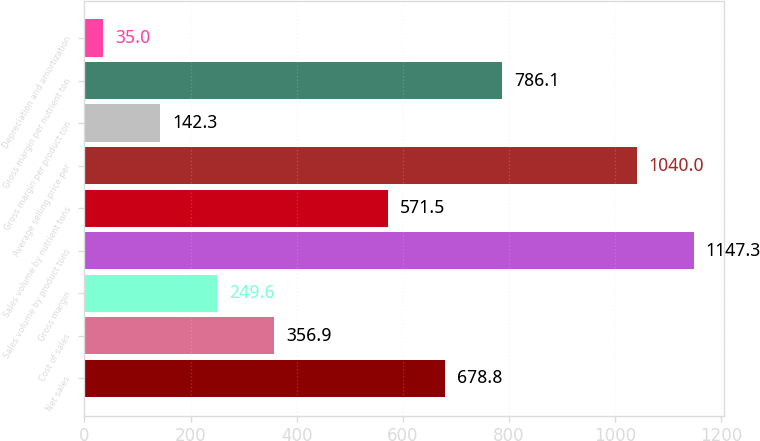<chart> <loc_0><loc_0><loc_500><loc_500><bar_chart><fcel>Net sales<fcel>Cost of sales<fcel>Gross margin<fcel>Sales volume by product tons<fcel>Sales volume by nutrient tons<fcel>Average selling price per<fcel>Gross margin per product ton<fcel>Gross margin per nutrient ton<fcel>Depreciation and amortization<nl><fcel>678.8<fcel>356.9<fcel>249.6<fcel>1147.3<fcel>571.5<fcel>1040<fcel>142.3<fcel>786.1<fcel>35<nl></chart> 